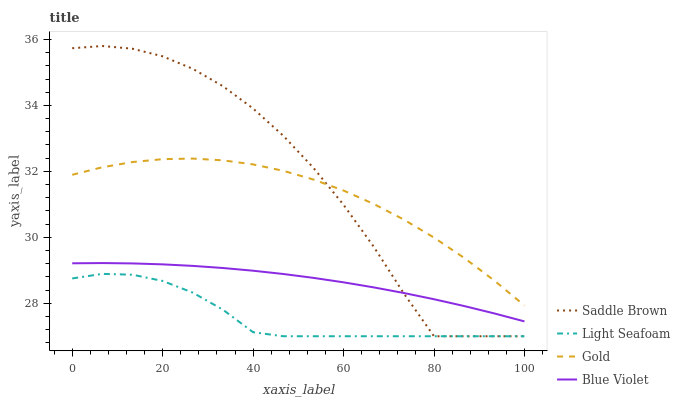Does Light Seafoam have the minimum area under the curve?
Answer yes or no. Yes. Does Saddle Brown have the maximum area under the curve?
Answer yes or no. Yes. Does Saddle Brown have the minimum area under the curve?
Answer yes or no. No. Does Light Seafoam have the maximum area under the curve?
Answer yes or no. No. Is Blue Violet the smoothest?
Answer yes or no. Yes. Is Saddle Brown the roughest?
Answer yes or no. Yes. Is Light Seafoam the smoothest?
Answer yes or no. No. Is Light Seafoam the roughest?
Answer yes or no. No. Does Light Seafoam have the lowest value?
Answer yes or no. Yes. Does Gold have the lowest value?
Answer yes or no. No. Does Saddle Brown have the highest value?
Answer yes or no. Yes. Does Light Seafoam have the highest value?
Answer yes or no. No. Is Light Seafoam less than Gold?
Answer yes or no. Yes. Is Blue Violet greater than Light Seafoam?
Answer yes or no. Yes. Does Gold intersect Saddle Brown?
Answer yes or no. Yes. Is Gold less than Saddle Brown?
Answer yes or no. No. Is Gold greater than Saddle Brown?
Answer yes or no. No. Does Light Seafoam intersect Gold?
Answer yes or no. No. 